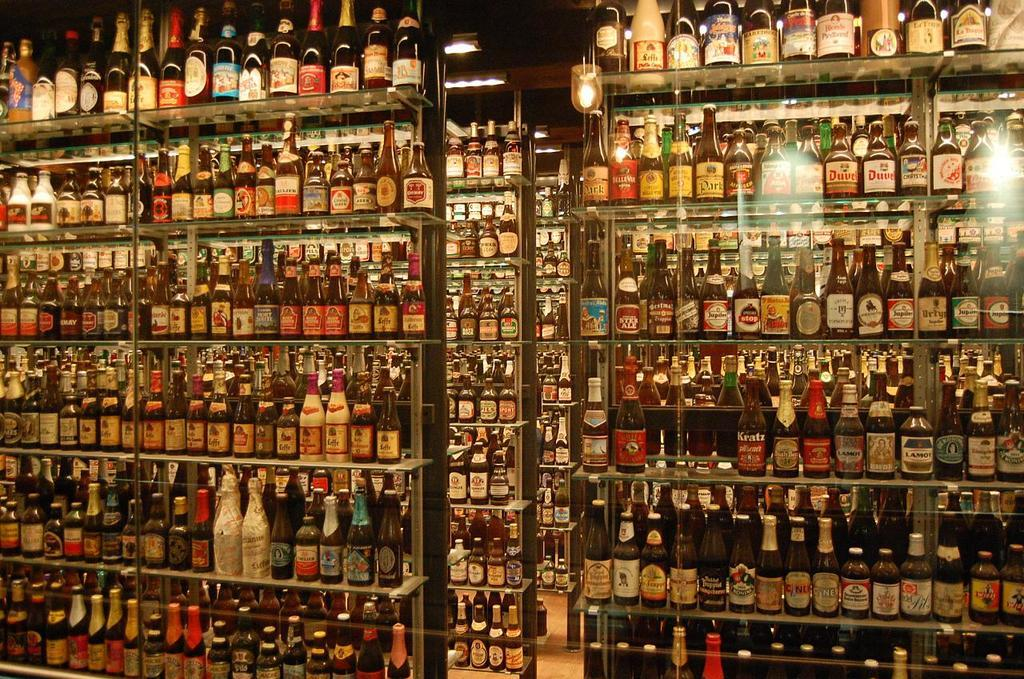What can be seen in the image that is used for storage? There are racks in the image that are used for storage. What is stored on the racks? Bottles are arranged on the racks. How are the bottles arranged on the racks? The arrangement of the bottles is in an order. Where was the image taken? The image was clicked inside a room. Can you tell me how many questions are present in the image? There are no questions visible in the image; it features racks with bottles arranged in an order inside a room. Is there any quicksand visible in the image? There is no quicksand present in the image; it features racks with bottles arranged in an order inside a room. 